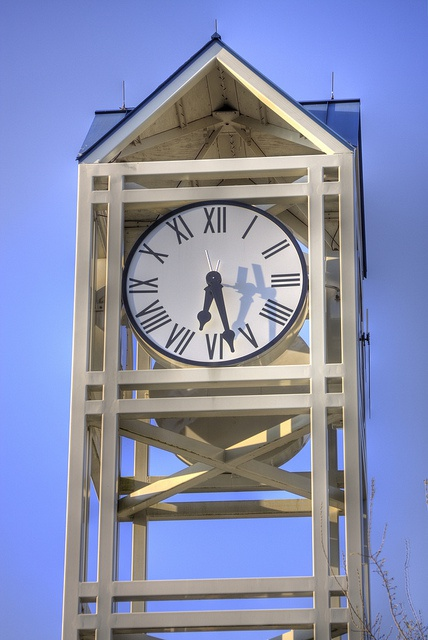Describe the objects in this image and their specific colors. I can see a clock in gray, darkgray, and lightgray tones in this image. 